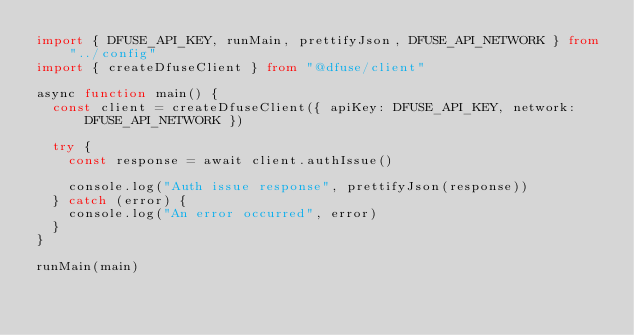<code> <loc_0><loc_0><loc_500><loc_500><_TypeScript_>import { DFUSE_API_KEY, runMain, prettifyJson, DFUSE_API_NETWORK } from "../config"
import { createDfuseClient } from "@dfuse/client"

async function main() {
  const client = createDfuseClient({ apiKey: DFUSE_API_KEY, network: DFUSE_API_NETWORK })

  try {
    const response = await client.authIssue()

    console.log("Auth issue response", prettifyJson(response))
  } catch (error) {
    console.log("An error occurred", error)
  }
}

runMain(main)
</code> 